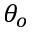Convert formula to latex. <formula><loc_0><loc_0><loc_500><loc_500>\theta _ { o }</formula> 